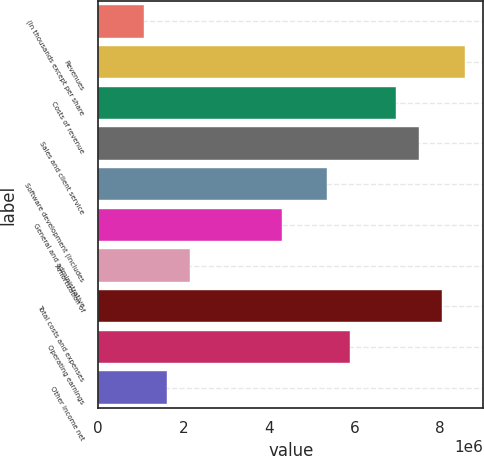Convert chart. <chart><loc_0><loc_0><loc_500><loc_500><bar_chart><fcel>(In thousands except per share<fcel>Revenues<fcel>Costs of revenue<fcel>Sales and client service<fcel>Software development (Includes<fcel>General and administrative<fcel>Amortization of<fcel>Total costs and expenses<fcel>Operating earnings<fcel>Other income net<nl><fcel>1.07327e+06<fcel>8.58612e+06<fcel>6.97622e+06<fcel>7.51285e+06<fcel>5.36632e+06<fcel>4.29306e+06<fcel>2.14653e+06<fcel>8.04949e+06<fcel>5.90296e+06<fcel>1.6099e+06<nl></chart> 